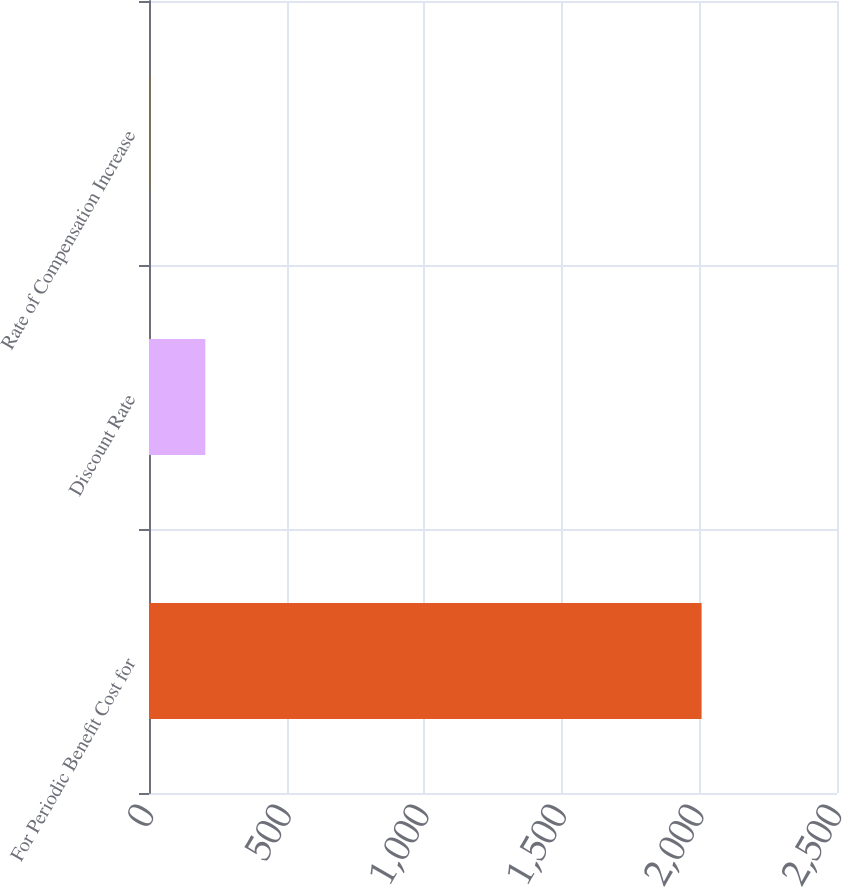Convert chart. <chart><loc_0><loc_0><loc_500><loc_500><bar_chart><fcel>For Periodic Benefit Cost for<fcel>Discount Rate<fcel>Rate of Compensation Increase<nl><fcel>2008<fcel>204.85<fcel>4.5<nl></chart> 